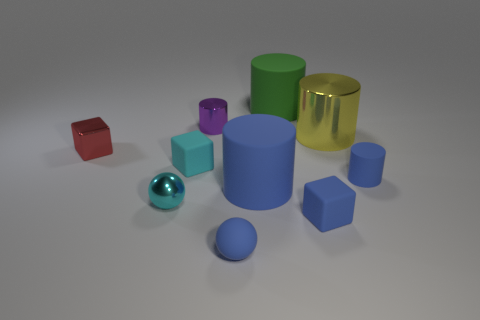Subtract all blue cylinders. How many were subtracted if there are1blue cylinders left? 1 Subtract all yellow metal cylinders. How many cylinders are left? 4 Subtract all yellow cylinders. How many cylinders are left? 4 Subtract all spheres. How many objects are left? 8 Subtract 1 balls. How many balls are left? 1 Subtract all purple cubes. Subtract all brown balls. How many cubes are left? 3 Subtract all brown cylinders. How many cyan blocks are left? 1 Subtract all purple cylinders. Subtract all red metal balls. How many objects are left? 9 Add 7 big yellow cylinders. How many big yellow cylinders are left? 8 Add 1 cyan rubber objects. How many cyan rubber objects exist? 2 